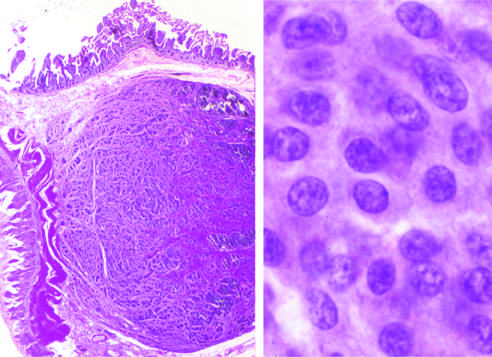do the cytologic features of cis form a submucosal nodule composed of tumor cells embedded in dense fibrous tissue?
Answer the question using a single word or phrase. No 